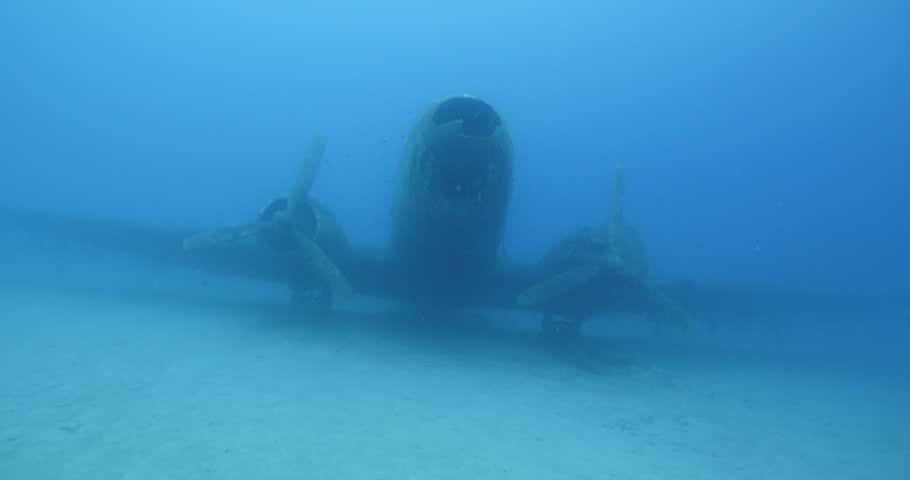Is this kind of underwater site open for divers to explore? Yes, shipwrecks and plane wrecks like this one are often popular dive sites, attracting recreational divers. They're interesting for exploration, observing how marine life interact with the wreck, and for the unique history they represent. What should divers be cautious about when exploring such sites? Divers should be cautious about the potential hazards such as sharp edges, entanglement risks, and the structural stability of the wreck. It's also important to respect the site and not disturb the marine life or remove any artifacts. 